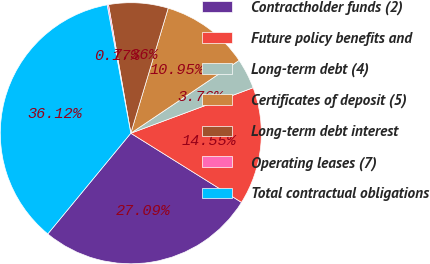Convert chart to OTSL. <chart><loc_0><loc_0><loc_500><loc_500><pie_chart><fcel>Contractholder funds (2)<fcel>Future policy benefits and<fcel>Long-term debt (4)<fcel>Certificates of deposit (5)<fcel>Long-term debt interest<fcel>Operating leases (7)<fcel>Total contractual obligations<nl><fcel>27.09%<fcel>14.55%<fcel>3.76%<fcel>10.95%<fcel>7.36%<fcel>0.17%<fcel>36.12%<nl></chart> 